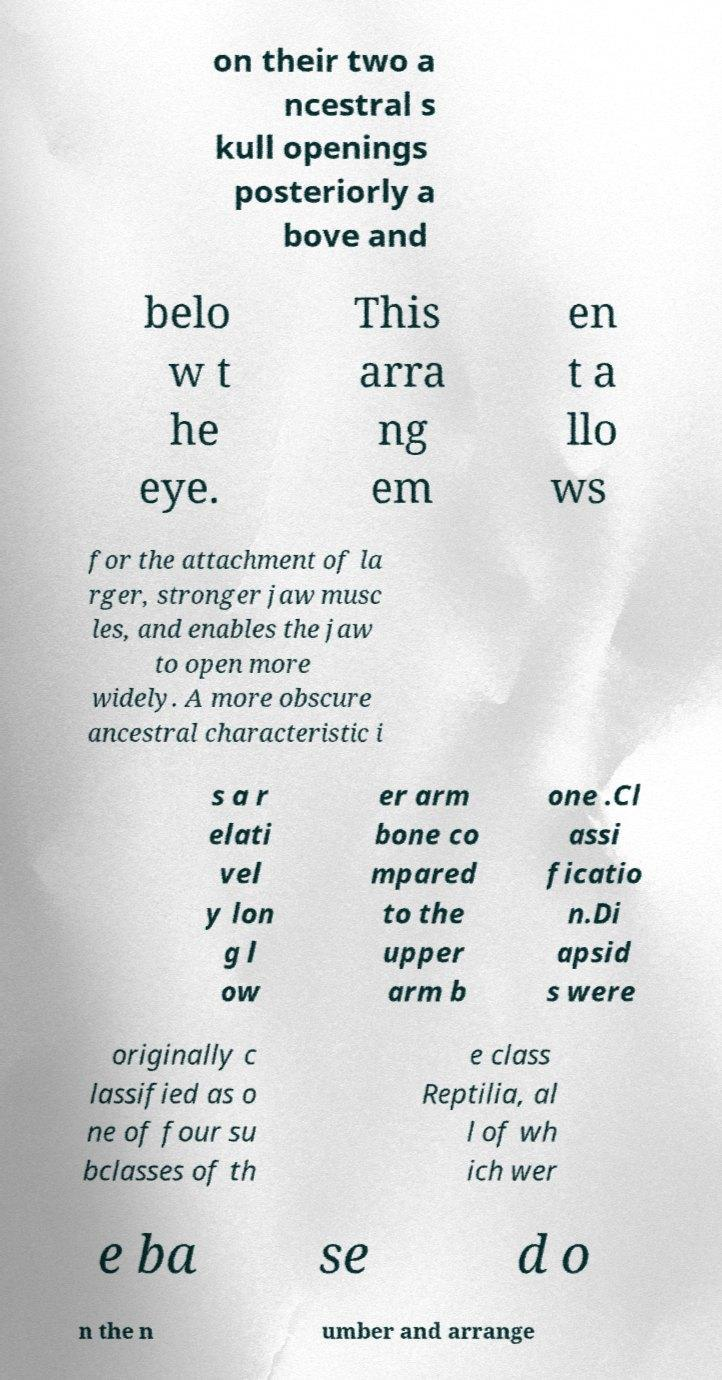Could you extract and type out the text from this image? on their two a ncestral s kull openings posteriorly a bove and belo w t he eye. This arra ng em en t a llo ws for the attachment of la rger, stronger jaw musc les, and enables the jaw to open more widely. A more obscure ancestral characteristic i s a r elati vel y lon g l ow er arm bone co mpared to the upper arm b one .Cl assi ficatio n.Di apsid s were originally c lassified as o ne of four su bclasses of th e class Reptilia, al l of wh ich wer e ba se d o n the n umber and arrange 